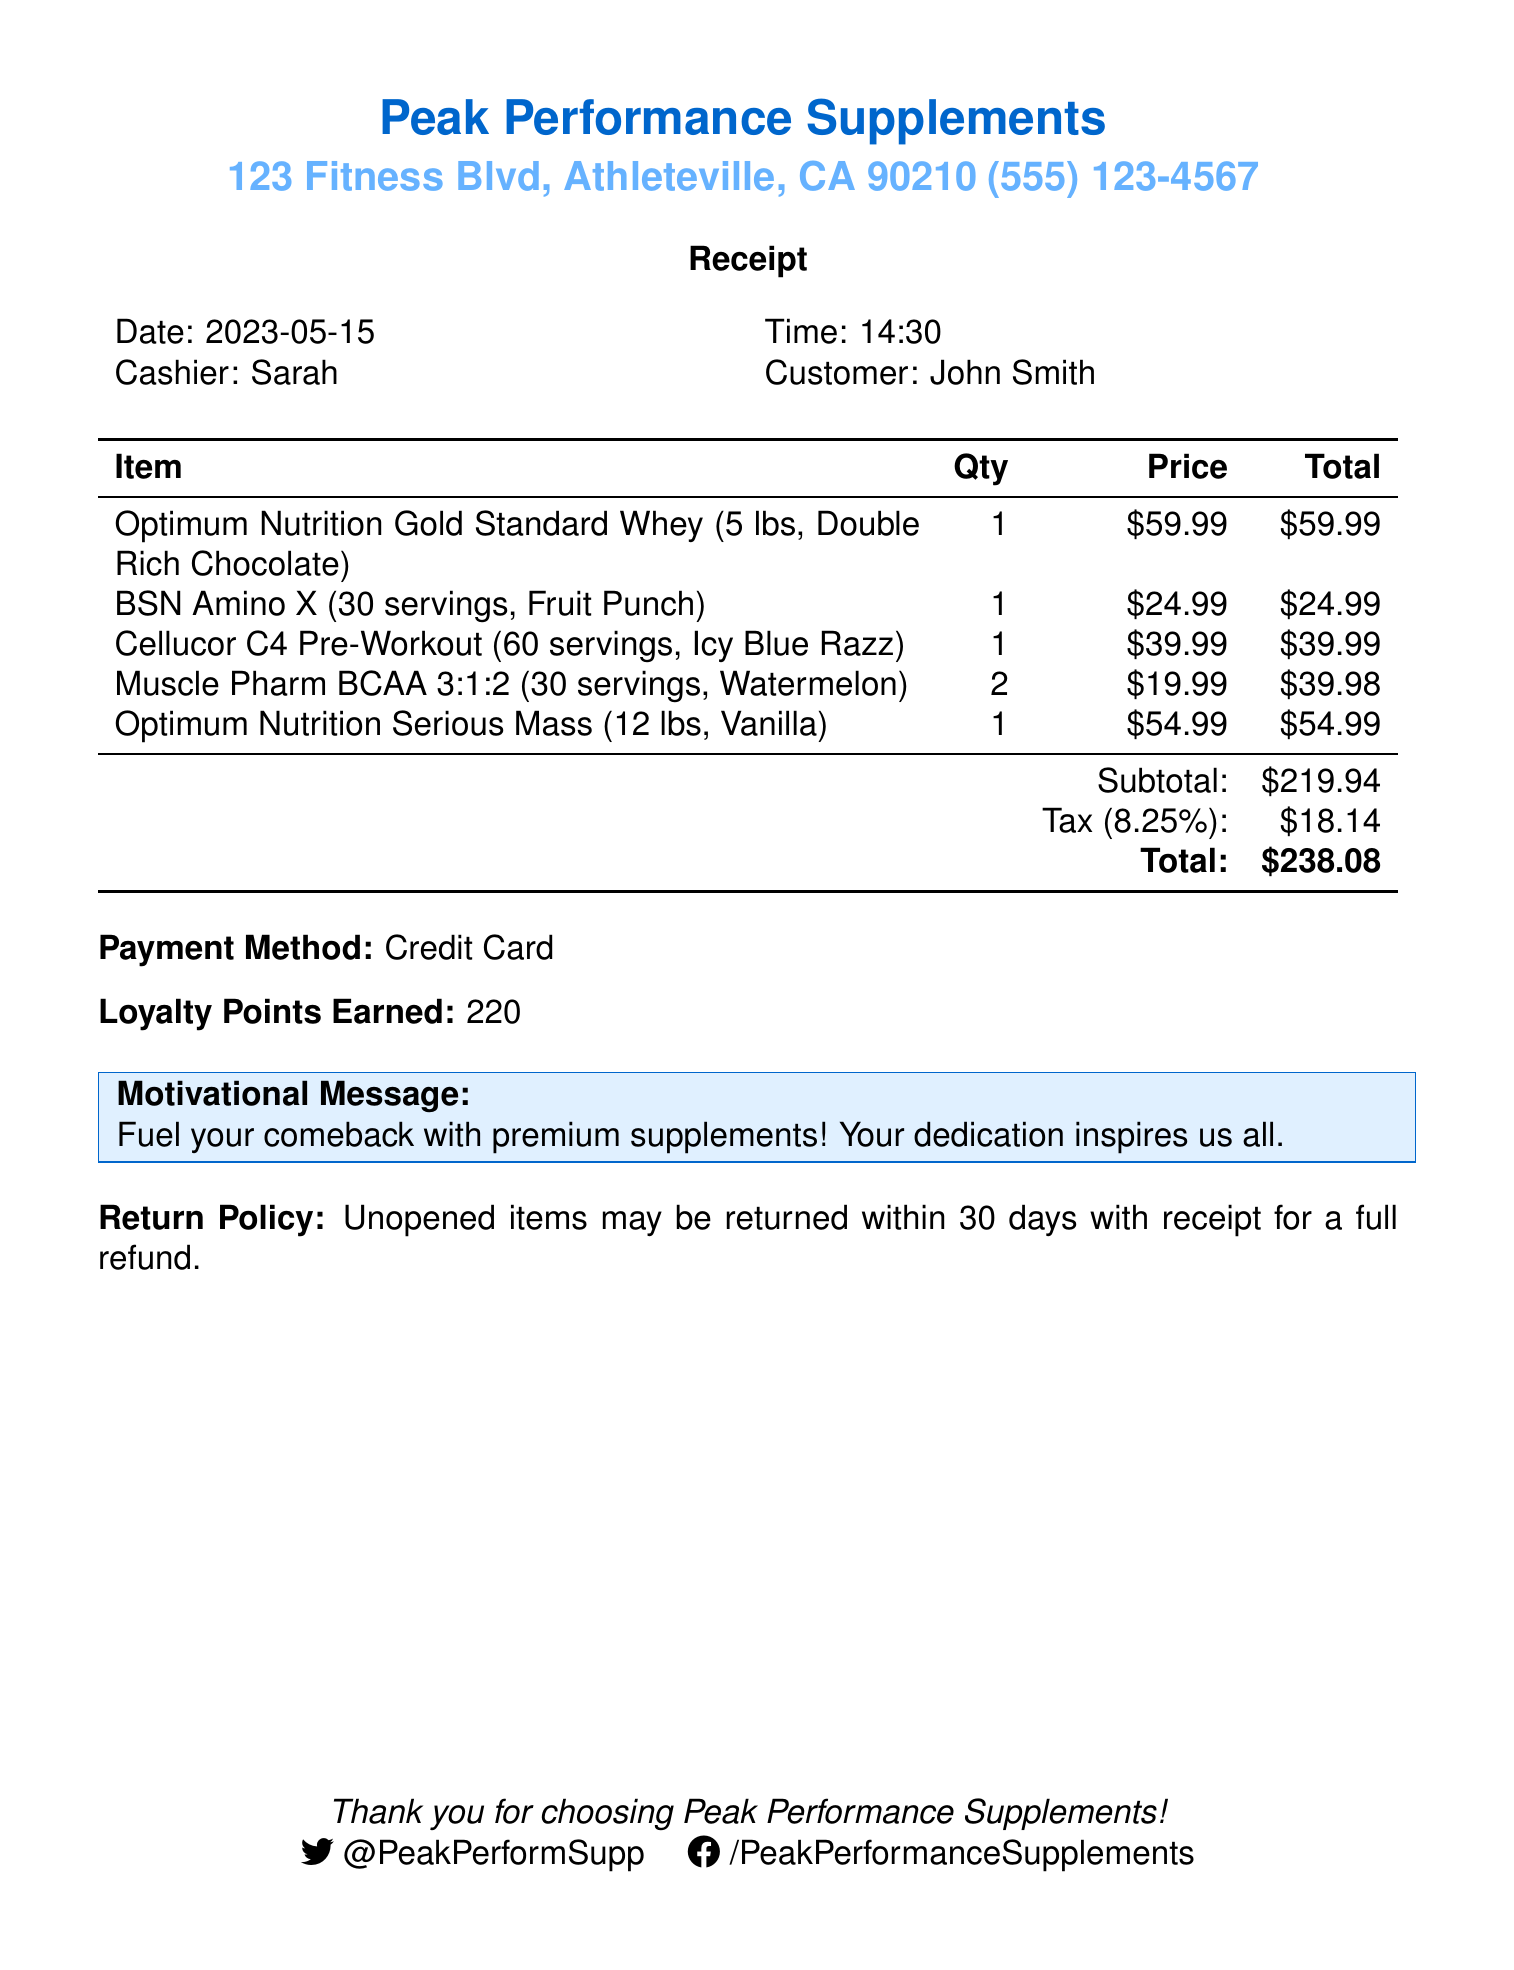What is the store name? The store name is listed at the top of the receipt.
Answer: Peak Performance Supplements When was the purchase made? The date of the purchase is specified in the receipt details.
Answer: 2023-05-15 How much did the BSN Amino X cost? The price of the BSN Amino X is shown in the itemized list.
Answer: $24.99 What is the total amount after tax? The total amount is indicated at the bottom of the receipt, including tax.
Answer: $238.08 How many loyalty points were earned? The loyalty points earned are stated near the payment method.
Answer: 220 What is the tax rate applied on the purchase? The tax rate is expressed in the tax section of the receipt.
Answer: 8.25% How many servings are in the Cellucor C4 Pre-Workout? The number of servings for the Cellucor C4 Pre-Workout is included in the item description.
Answer: 60 servings What is the return policy stated in the receipt? The return policy is mentioned towards the end of the document.
Answer: Unopened items may be returned within 30 days with receipt for a full refund Who was the cashier during the purchase? The cashier's name is provided alongside the purchase details.
Answer: Sarah 